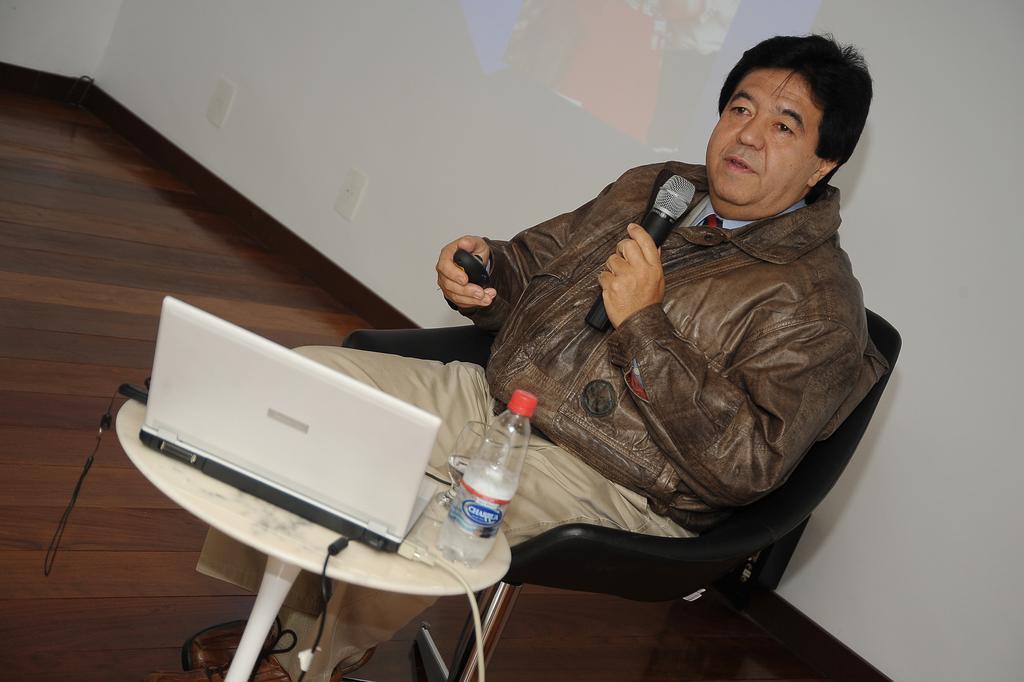Can you describe this image briefly? In the center we can see one person sitting on chair. In front we can see table and on table we can see tab and bottle,glass. He is holding remote and microphone. And back we can see screen. 